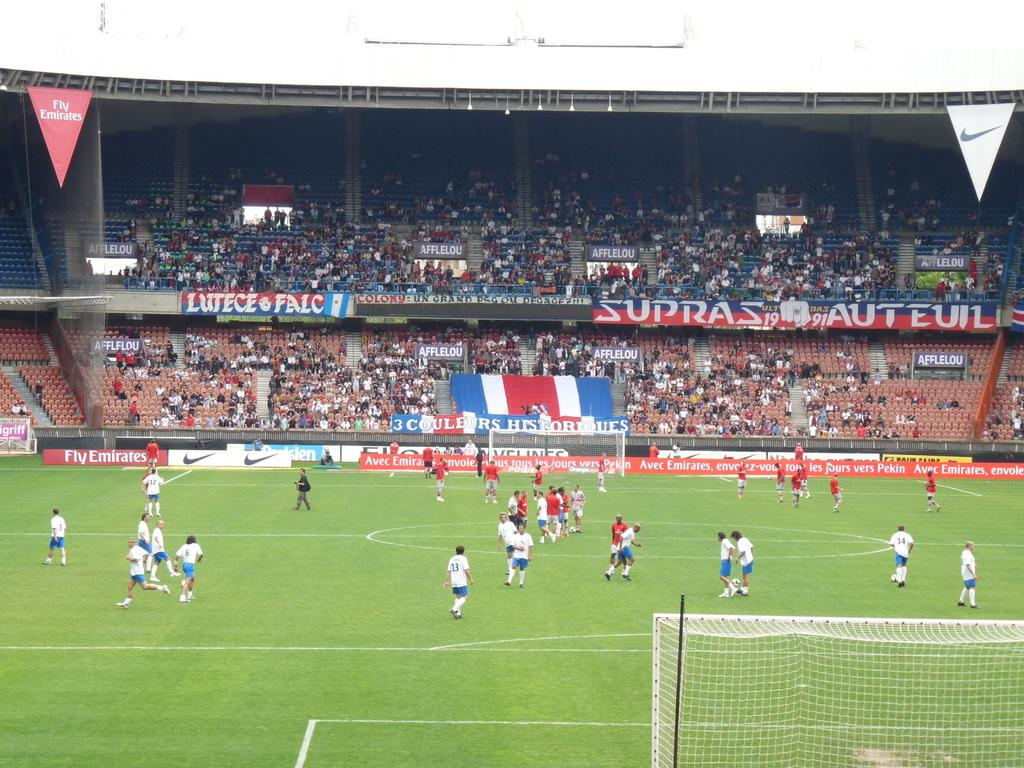What type of activity is being performed by the players in the image? The players are engaged in an activity that requires a net, which suggests it could be a sport like tennis or volleyball. Where are the players located in the image? The players are in a stadium, as indicated by the presence of a boundary wall and seating for spectators. Can you describe the people sitting in the image? There are people sitting in the image, likely spectators watching the players. What is the purpose of the net in the image? The net is used to separate the playing area and create a boundary for the game being played. What are the cloth banners in the image used for? The cloth banners in the image are likely used for advertising or displaying team names or logos. What type of plastic material is used to make the lead pipes in the image? There are no lead pipes present in the image; it features players in a stadium with a net and cloth banners. 